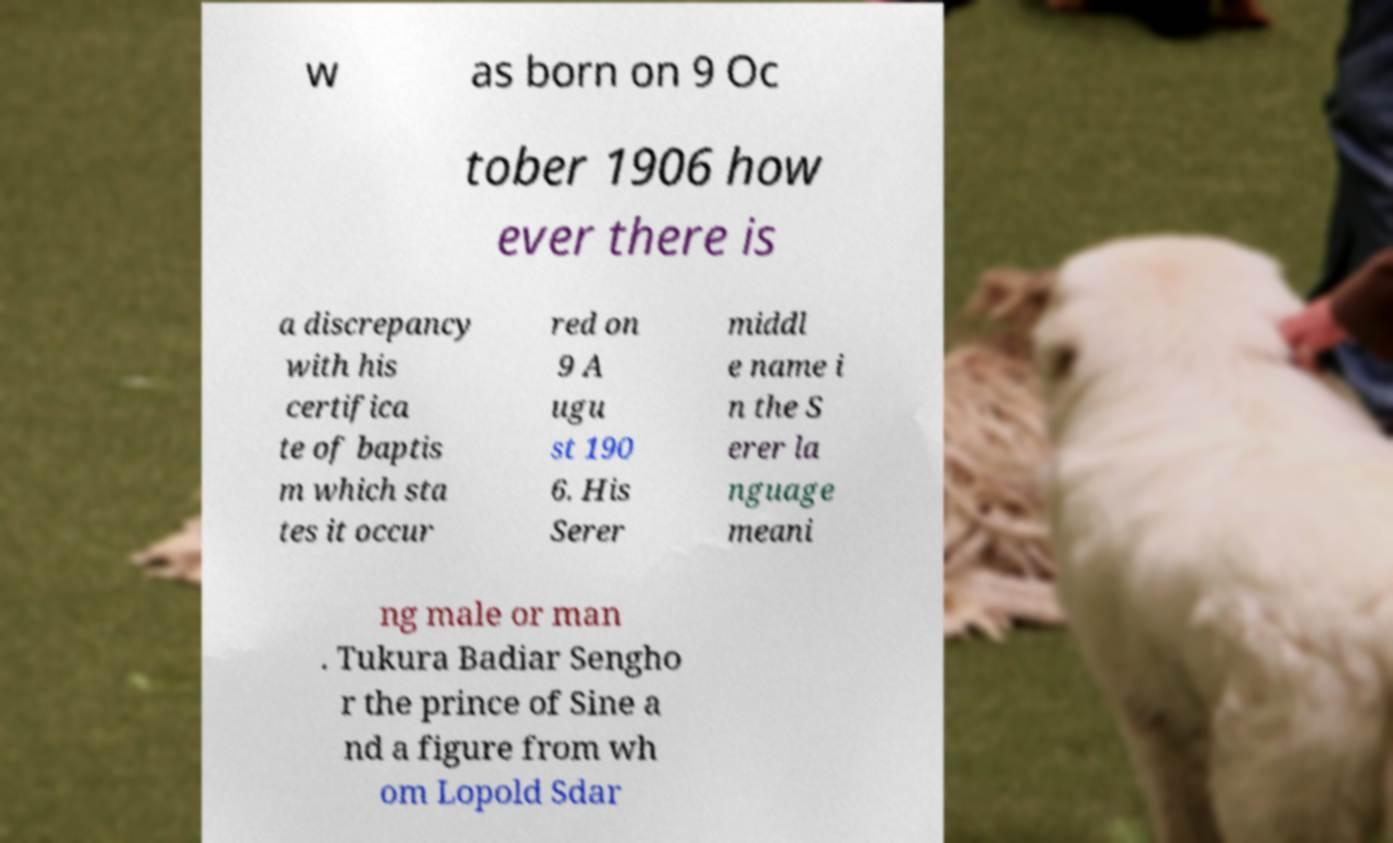I need the written content from this picture converted into text. Can you do that? w as born on 9 Oc tober 1906 how ever there is a discrepancy with his certifica te of baptis m which sta tes it occur red on 9 A ugu st 190 6. His Serer middl e name i n the S erer la nguage meani ng male or man . Tukura Badiar Sengho r the prince of Sine a nd a figure from wh om Lopold Sdar 